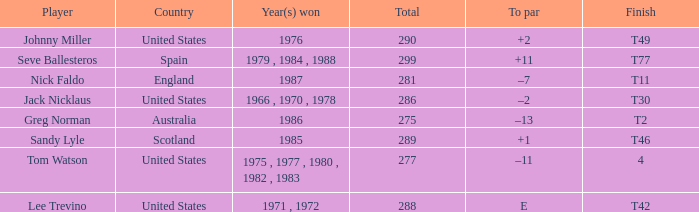A t49 finish happened in which country? United States. 